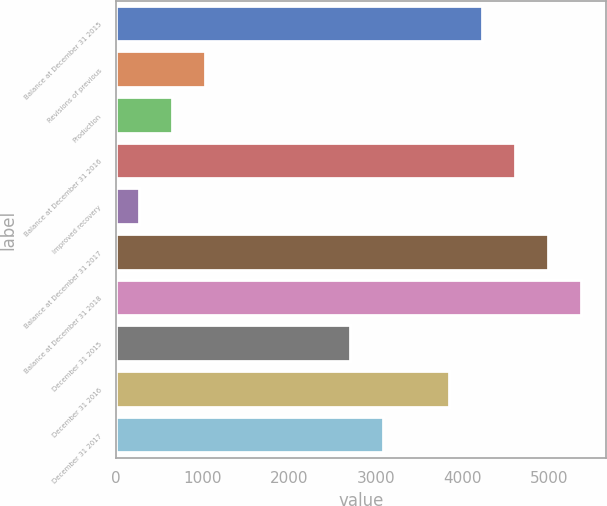Convert chart. <chart><loc_0><loc_0><loc_500><loc_500><bar_chart><fcel>Balance at December 31 2015<fcel>Revisions of previous<fcel>Production<fcel>Balance at December 31 2016<fcel>Improved recovery<fcel>Balance at December 31 2017<fcel>Balance at December 31 2018<fcel>December 31 2015<fcel>December 31 2016<fcel>December 31 2017<nl><fcel>4232.4<fcel>1038.2<fcel>656.1<fcel>4614.5<fcel>274<fcel>4996.6<fcel>5378.7<fcel>2704<fcel>3850.3<fcel>3086.1<nl></chart> 